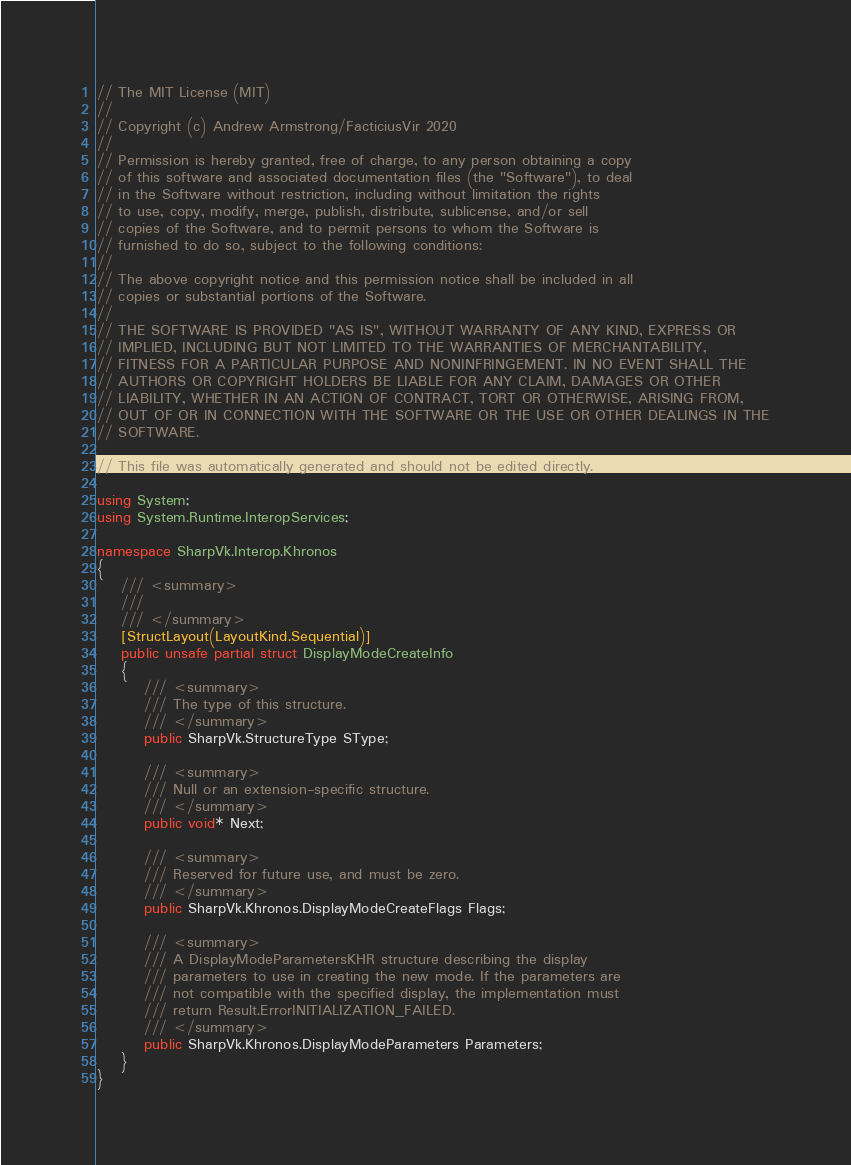Convert code to text. <code><loc_0><loc_0><loc_500><loc_500><_C#_>// The MIT License (MIT)
// 
// Copyright (c) Andrew Armstrong/FacticiusVir 2020
// 
// Permission is hereby granted, free of charge, to any person obtaining a copy
// of this software and associated documentation files (the "Software"), to deal
// in the Software without restriction, including without limitation the rights
// to use, copy, modify, merge, publish, distribute, sublicense, and/or sell
// copies of the Software, and to permit persons to whom the Software is
// furnished to do so, subject to the following conditions:
// 
// The above copyright notice and this permission notice shall be included in all
// copies or substantial portions of the Software.
// 
// THE SOFTWARE IS PROVIDED "AS IS", WITHOUT WARRANTY OF ANY KIND, EXPRESS OR
// IMPLIED, INCLUDING BUT NOT LIMITED TO THE WARRANTIES OF MERCHANTABILITY,
// FITNESS FOR A PARTICULAR PURPOSE AND NONINFRINGEMENT. IN NO EVENT SHALL THE
// AUTHORS OR COPYRIGHT HOLDERS BE LIABLE FOR ANY CLAIM, DAMAGES OR OTHER
// LIABILITY, WHETHER IN AN ACTION OF CONTRACT, TORT OR OTHERWISE, ARISING FROM,
// OUT OF OR IN CONNECTION WITH THE SOFTWARE OR THE USE OR OTHER DEALINGS IN THE
// SOFTWARE.

// This file was automatically generated and should not be edited directly.

using System;
using System.Runtime.InteropServices;

namespace SharpVk.Interop.Khronos
{
    /// <summary>
    /// 
    /// </summary>
    [StructLayout(LayoutKind.Sequential)]
    public unsafe partial struct DisplayModeCreateInfo
    {
        /// <summary>
        /// The type of this structure.
        /// </summary>
        public SharpVk.StructureType SType; 
        
        /// <summary>
        /// Null or an extension-specific structure.
        /// </summary>
        public void* Next; 
        
        /// <summary>
        /// Reserved for future use, and must be zero.
        /// </summary>
        public SharpVk.Khronos.DisplayModeCreateFlags Flags; 
        
        /// <summary>
        /// A DisplayModeParametersKHR structure describing the display
        /// parameters to use in creating the new mode. If the parameters are
        /// not compatible with the specified display, the implementation must
        /// return Result.ErrorINITIALIZATION_FAILED.
        /// </summary>
        public SharpVk.Khronos.DisplayModeParameters Parameters; 
    }
}
</code> 